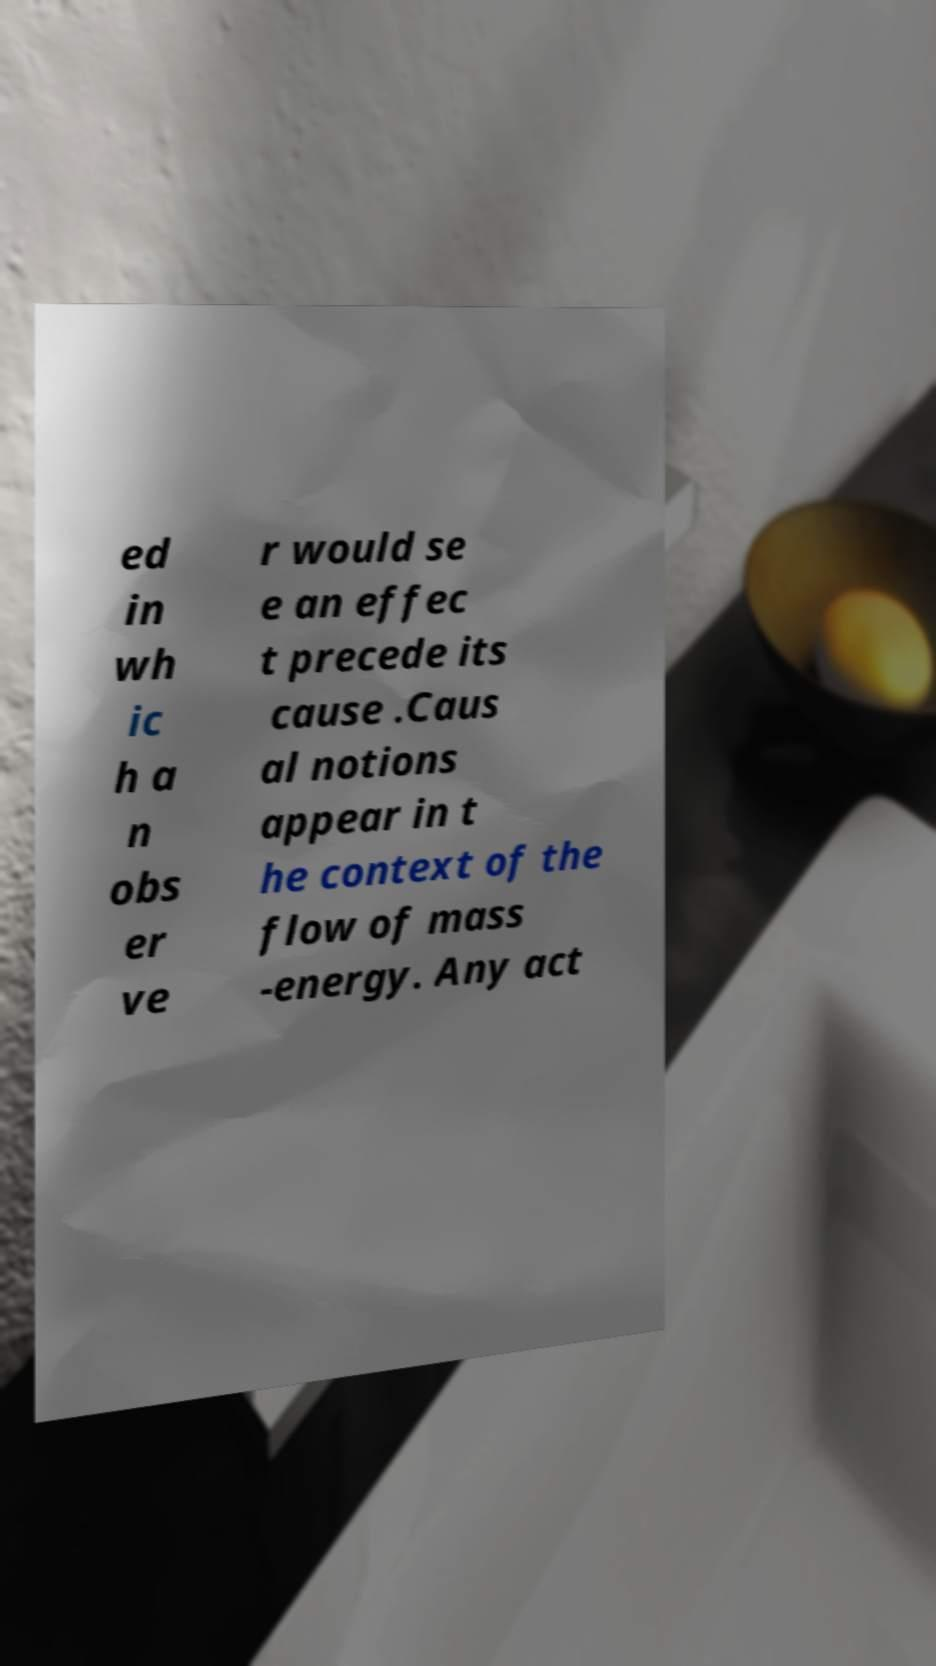There's text embedded in this image that I need extracted. Can you transcribe it verbatim? ed in wh ic h a n obs er ve r would se e an effec t precede its cause .Caus al notions appear in t he context of the flow of mass -energy. Any act 